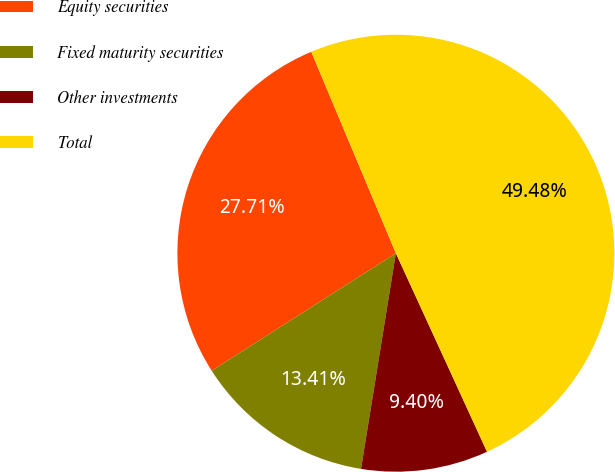<chart> <loc_0><loc_0><loc_500><loc_500><pie_chart><fcel>Equity securities<fcel>Fixed maturity securities<fcel>Other investments<fcel>Total<nl><fcel>27.71%<fcel>13.41%<fcel>9.4%<fcel>49.48%<nl></chart> 